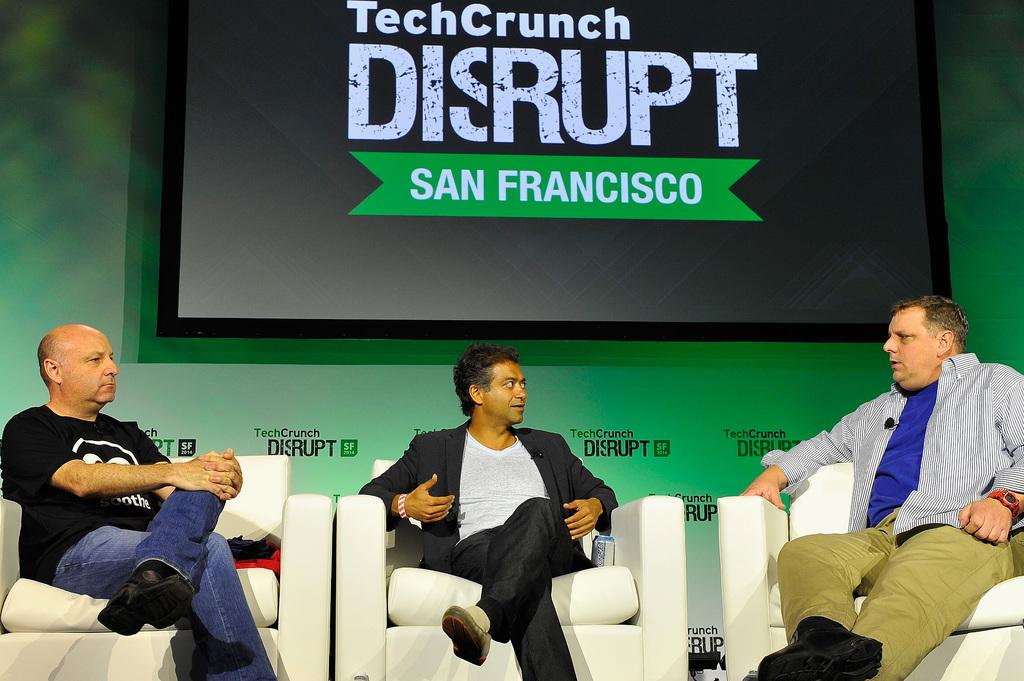How many men are in the image? There are three men in the image. What are the men doing in the image? The men are sitting on chairs. What can be seen in the background of the image? There is a wall and a screen in the background of the image. What type of feeling can be seen on the playground in the image? There is no playground present in the image. Is there a sidewalk visible in the image? There is no sidewalk visible in the image. 